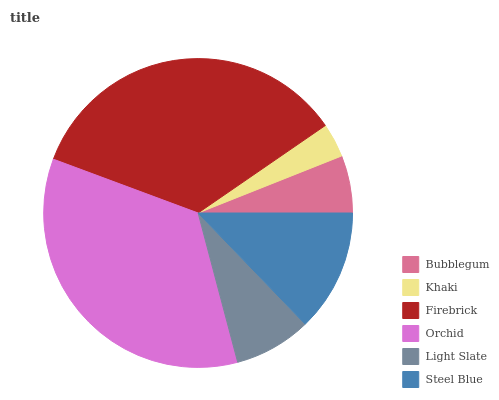Is Khaki the minimum?
Answer yes or no. Yes. Is Orchid the maximum?
Answer yes or no. Yes. Is Firebrick the minimum?
Answer yes or no. No. Is Firebrick the maximum?
Answer yes or no. No. Is Firebrick greater than Khaki?
Answer yes or no. Yes. Is Khaki less than Firebrick?
Answer yes or no. Yes. Is Khaki greater than Firebrick?
Answer yes or no. No. Is Firebrick less than Khaki?
Answer yes or no. No. Is Steel Blue the high median?
Answer yes or no. Yes. Is Light Slate the low median?
Answer yes or no. Yes. Is Light Slate the high median?
Answer yes or no. No. Is Khaki the low median?
Answer yes or no. No. 